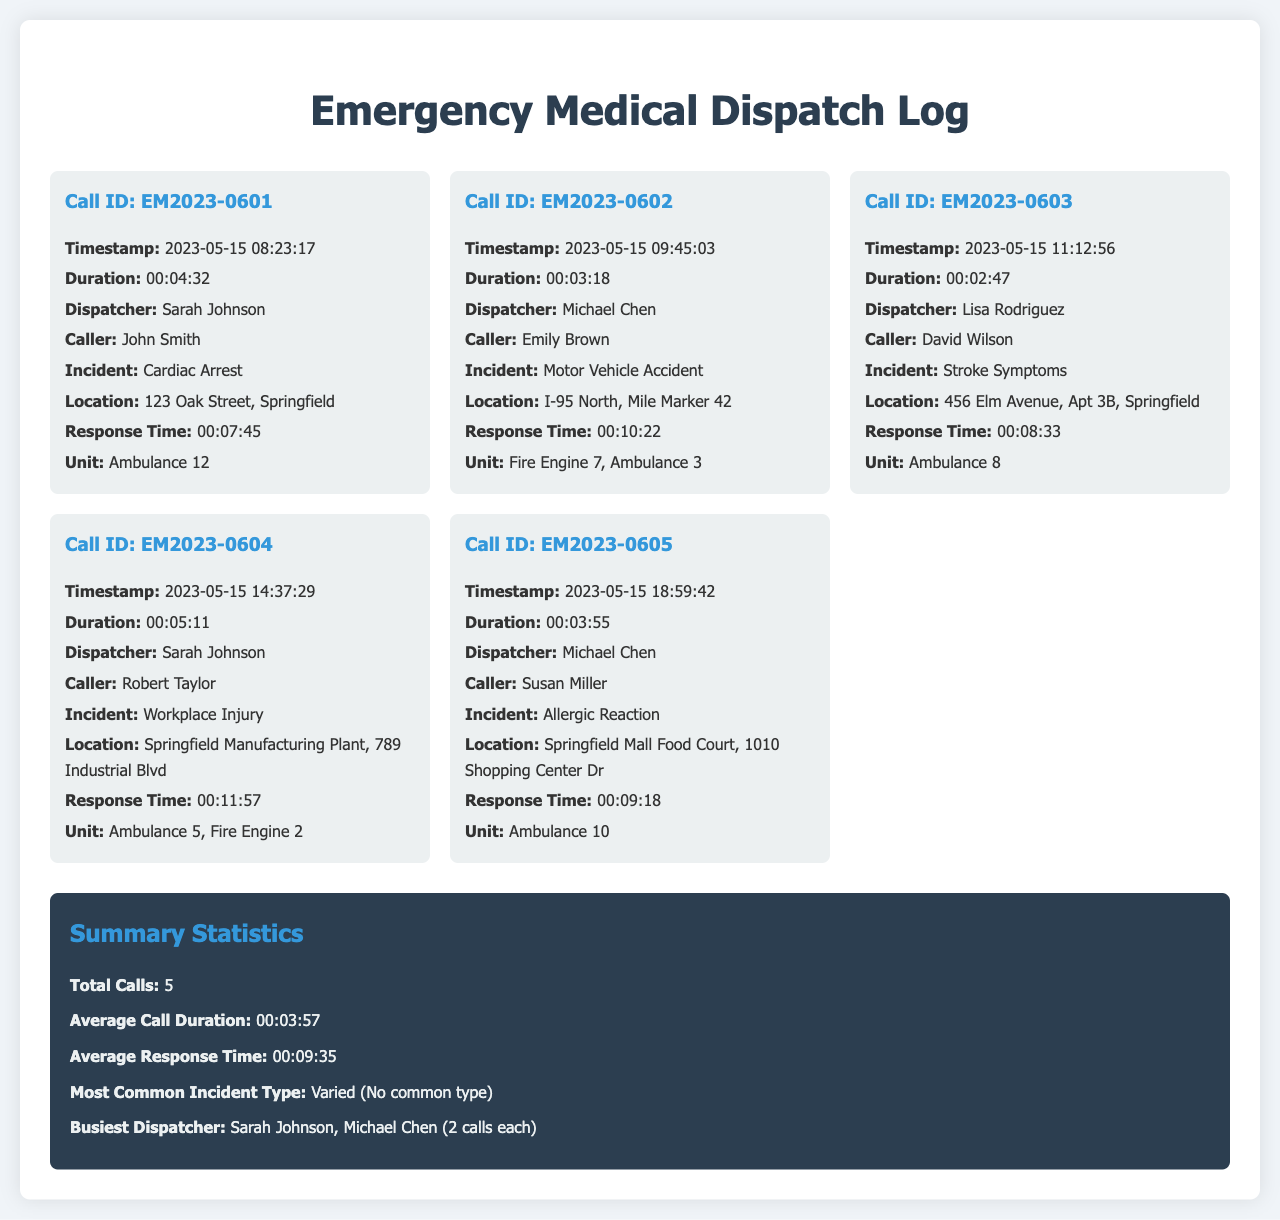What is the total number of calls? The document states that there are 5 calls listed in the emergency medical dispatch log.
Answer: 5 Who was the dispatcher for the call about Cardiac Arrest? The details of the call regarding Cardiac Arrest indicate that Sarah Johnson was the dispatcher.
Answer: Sarah Johnson What was the response time for the Motor Vehicle Accident call? The response time recorded for the Motor Vehicle Accident is 00:10:22, as per the call details.
Answer: 00:10:22 Which unit responded to the Stroke Symptoms incident? According to the incident details, Ambulance 8 was the unit that responded to the Stroke Symptoms.
Answer: Ambulance 8 What is the average response time across all calls? The document provides an average response time of 00:09:35 calculated from all the dispatches.
Answer: 00:09:35 Who called in the incident of Allergic Reaction? The details related to the Allergic Reaction indicate that Susan Miller was the caller for that incident.
Answer: Susan Miller What is the most common incident type mentioned in the call log? The analysis of the incidents shows that there was no common incident type, as per the summary statistics provided.
Answer: Varied (No common type) Which dispatcher handled the most calls? The summary indicates that both Sarah Johnson and Michael Chen handled the most calls, each with 2 calls.
Answer: Sarah Johnson, Michael Chen What was the call duration for the Workplace Injury incident? The call duration for the Workplace Injury incident is stated as 00:05:11 in the log.
Answer: 00:05:11 